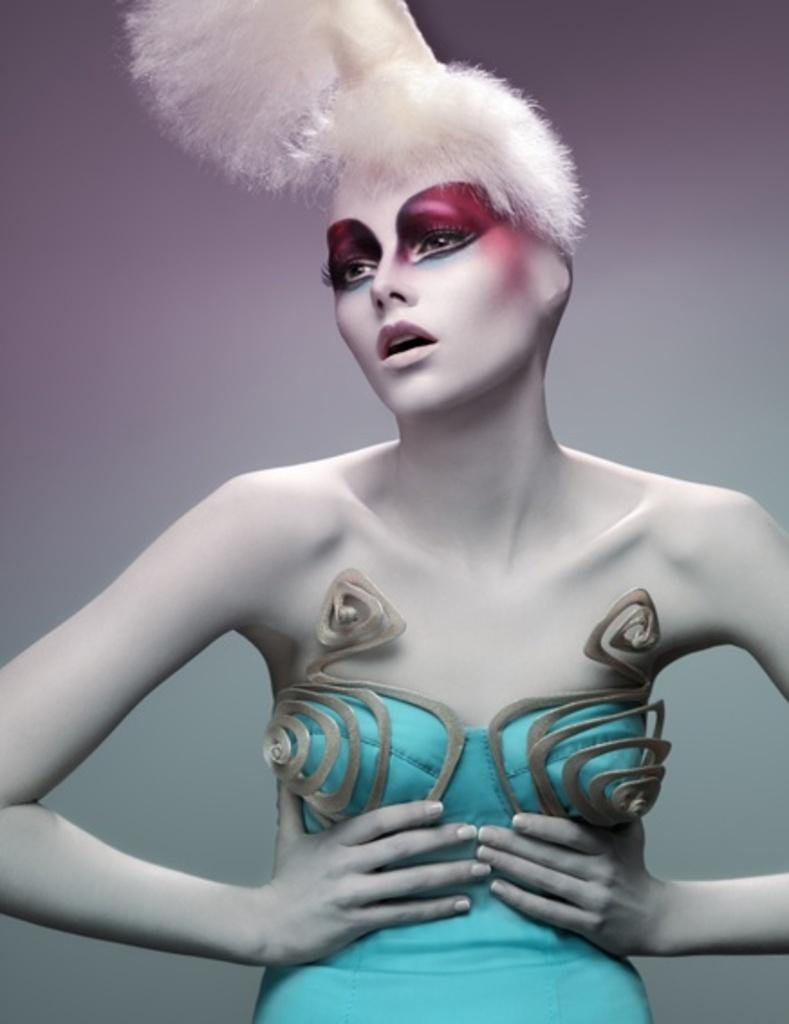Who is the main subject in the image? There is a lady in the image. What is the lady wearing? The lady is wearing a blue dress. How many cakes are on the table next to the lady in the image? There is no table or cakes present in the image; it only features a lady wearing a blue dress. 